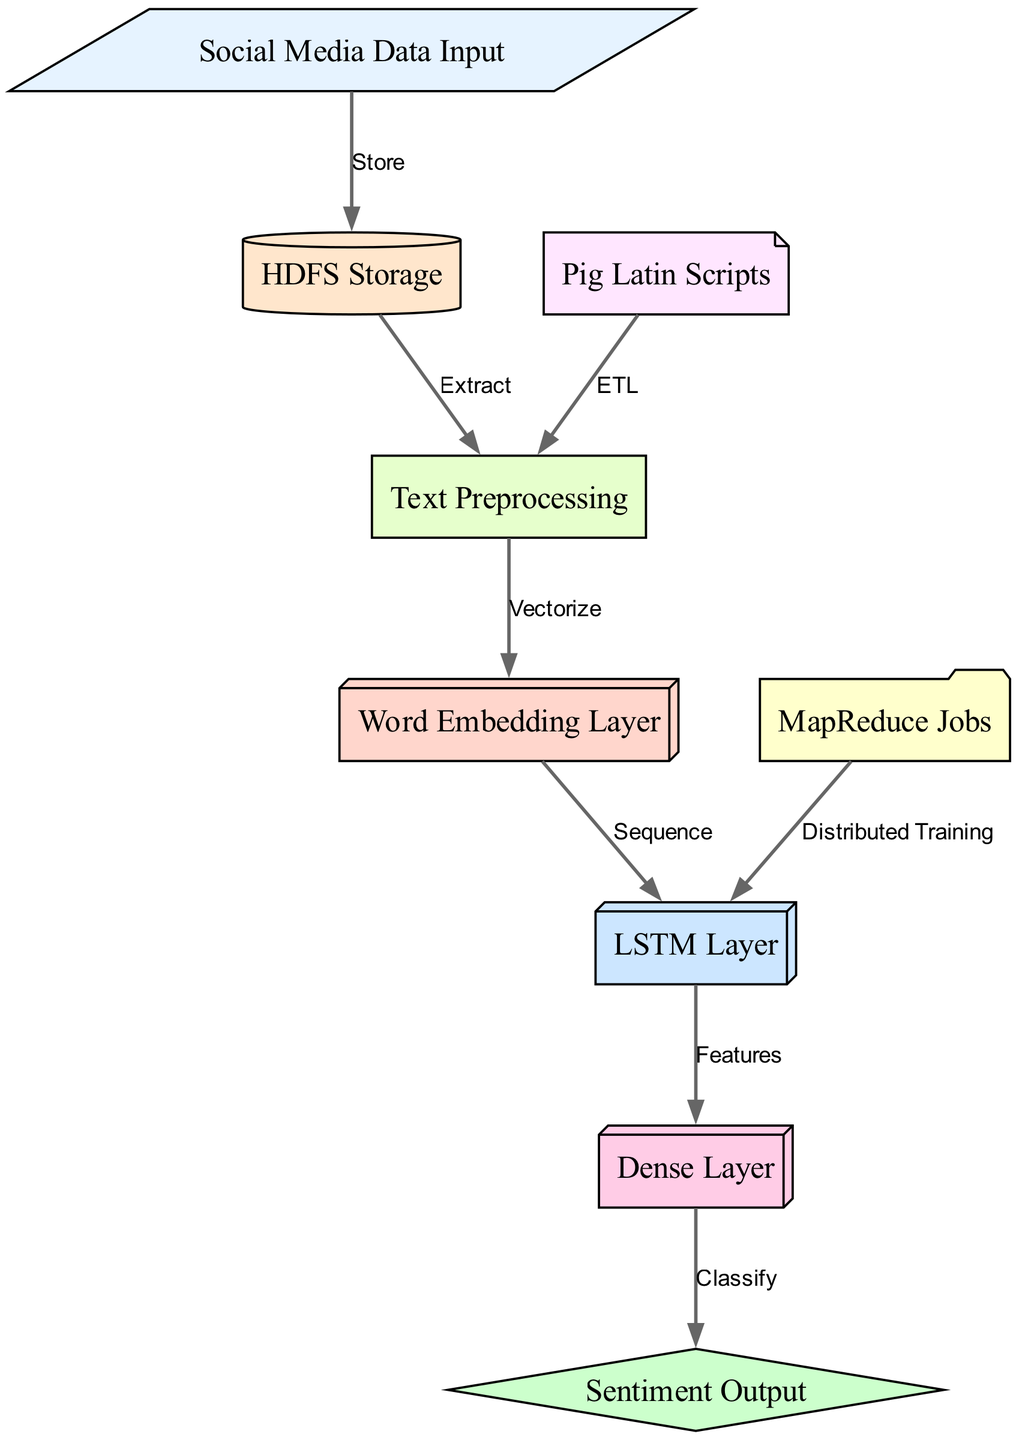What is the first node in the diagram? The first node shown in the diagram is labeled "Social Media Data Input". This can be identified as it is the starting point from which the other nodes and processes derive.
Answer: Social Media Data Input How many nodes are present in the diagram? By counting the listed nodes in the provided data (input, HDFS, preprocessing, embedding, LSTM, dense, output, Pig Latin scripts, and MapReduce jobs), we find that there are a total of 9 nodes.
Answer: 9 What is the role of the HDFS node? The HDFS node is responsible for storing data, as indicated by the edge labeled "Store" leading from the "Social Media Data Input" node to the "HDFS Storage" node.
Answer: Store Which layer comes immediately after the Text Preprocessing node? The layer that follows the Text Preprocessing node is the Word Embedding Layer, as per the arrow indicating the flow from preprocessing to embedding.
Answer: Word Embedding Layer How does the Dense Layer contribute to the workflow? The Dense Layer's role in the workflow is to classify features, as shown by the edge from the Dense Layer to the Sentiment Output labeled "Classify". It processes the output from the LSTM Layer to produce the final sentiment analysis results.
Answer: Classify What is the purpose of the Pig Latin scripts in the diagram? The Pig Latin scripts are used for the ETL (Extract, Transform, Load) process, which involves preparing and processing data before it flows into the preprocessing step, as denoted by the edge leading from Pig to preprocessing.
Answer: ETL Which node is involved in distributed training? The node responsible for distributed training is the LSTM Layer. This is inferred from the edge labeled "Distributed Training" that flows from the MapReduce jobs to the LSTM Layer.
Answer: LSTM Layer What signifies the nature of the output from the neural network? The output is represented by a diamond-shaped node labeled "Sentiment Output", which indicates that it delivers the classification results of sentiment analysis from the procured social media data.
Answer: Sentiment Output Which node handles the data storage aspect in the architecture? The data handling and storage are managed by the HDFS Storage node, signified by its central role in the workflow as indicated by the connections in the diagram.
Answer: HDFS Storage 